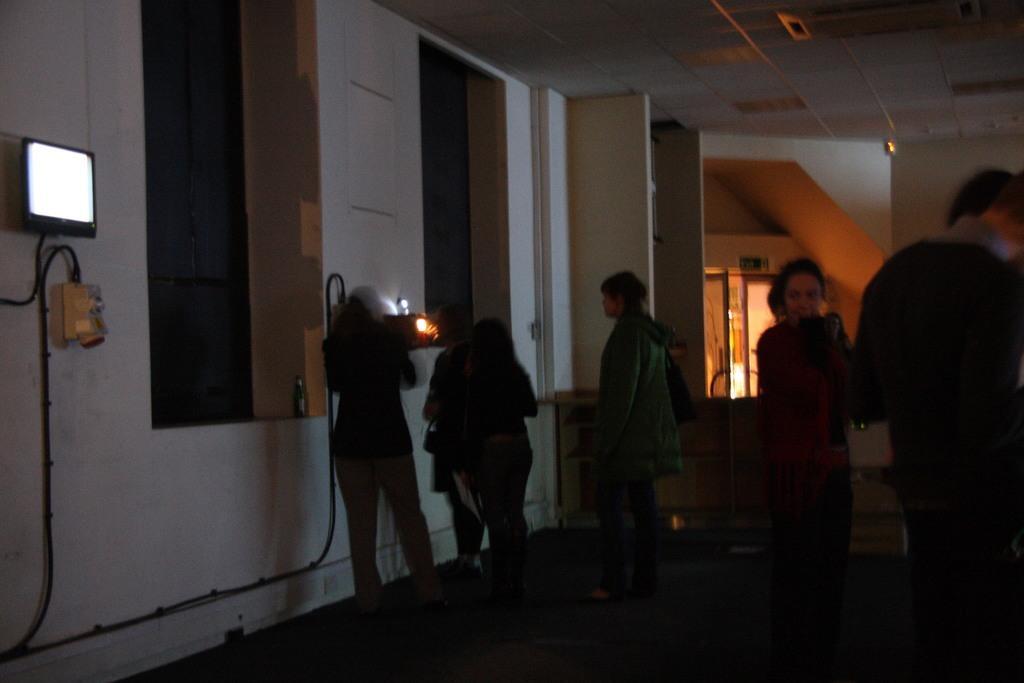Could you give a brief overview of what you see in this image? In this image we can see five people are standing in a room. The wall and the roof of the room is in white color. One monitor is attached to the wall on the left side of the image. In the middle of the image, one door is there. 